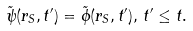Convert formula to latex. <formula><loc_0><loc_0><loc_500><loc_500>\tilde { \psi } ( r _ { S } , t ^ { \prime } ) = \tilde { \phi } ( r _ { S } , t ^ { \prime } ) , \, t ^ { \prime } \leq t .</formula> 